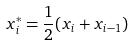Convert formula to latex. <formula><loc_0><loc_0><loc_500><loc_500>x _ { i } ^ { * } = \frac { 1 } { 2 } ( x _ { i } + x _ { i - 1 } )</formula> 